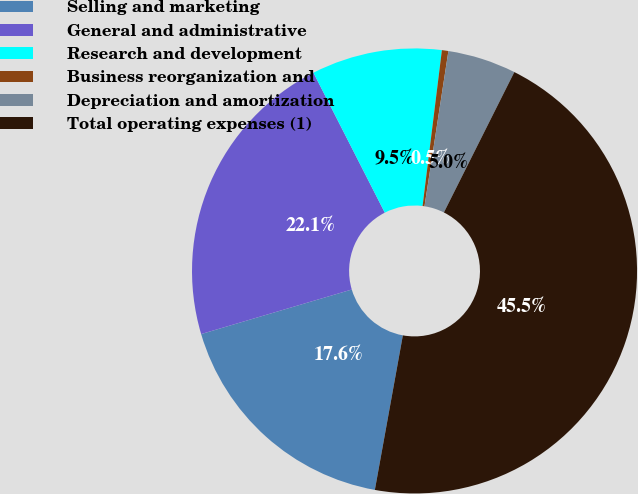Convert chart. <chart><loc_0><loc_0><loc_500><loc_500><pie_chart><fcel>Selling and marketing<fcel>General and administrative<fcel>Research and development<fcel>Business reorganization and<fcel>Depreciation and amortization<fcel>Total operating expenses (1)<nl><fcel>17.57%<fcel>22.07%<fcel>9.47%<fcel>0.47%<fcel>4.97%<fcel>45.45%<nl></chart> 